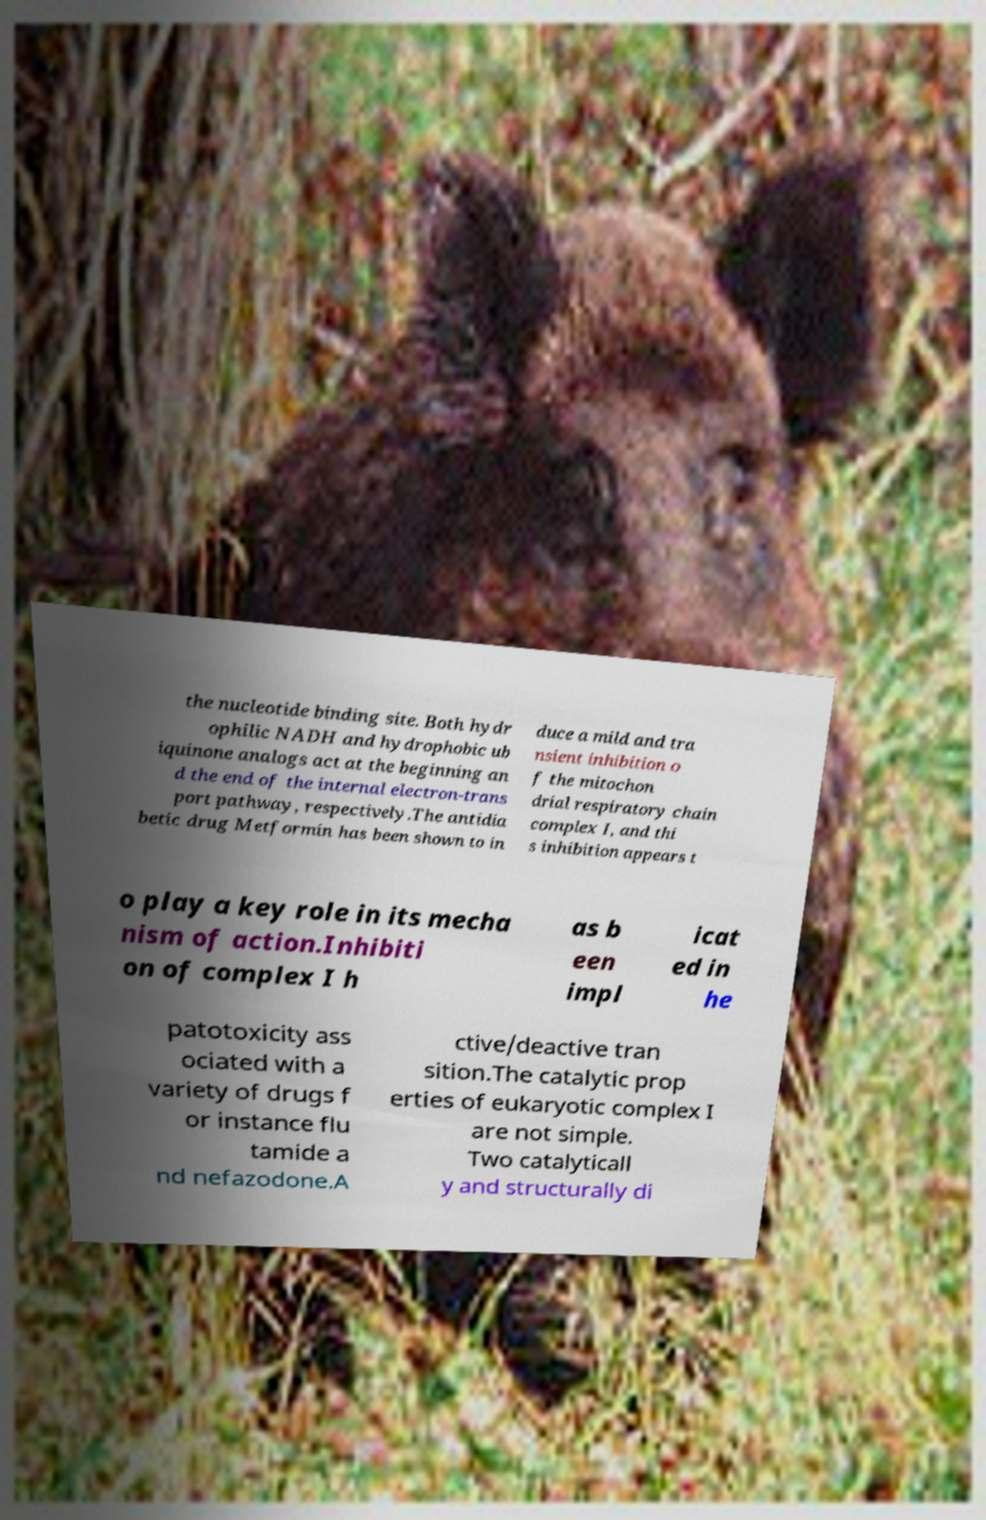Please identify and transcribe the text found in this image. the nucleotide binding site. Both hydr ophilic NADH and hydrophobic ub iquinone analogs act at the beginning an d the end of the internal electron-trans port pathway, respectively.The antidia betic drug Metformin has been shown to in duce a mild and tra nsient inhibition o f the mitochon drial respiratory chain complex I, and thi s inhibition appears t o play a key role in its mecha nism of action.Inhibiti on of complex I h as b een impl icat ed in he patotoxicity ass ociated with a variety of drugs f or instance flu tamide a nd nefazodone.A ctive/deactive tran sition.The catalytic prop erties of eukaryotic complex I are not simple. Two catalyticall y and structurally di 